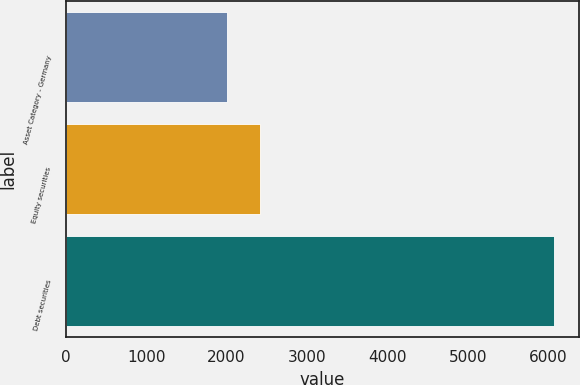Convert chart to OTSL. <chart><loc_0><loc_0><loc_500><loc_500><bar_chart><fcel>Asset Category - Germany<fcel>Equity securities<fcel>Debt securities<nl><fcel>2006<fcel>2413.4<fcel>6080<nl></chart> 